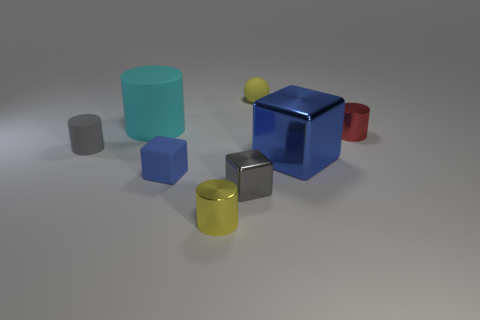There is a tiny yellow thing in front of the tiny yellow thing behind the yellow cylinder; what shape is it?
Ensure brevity in your answer.  Cylinder. There is a cyan matte thing; does it have the same shape as the gray thing that is left of the big rubber cylinder?
Ensure brevity in your answer.  Yes. How many blue blocks are to the right of the small yellow rubber sphere that is behind the blue matte cube?
Your response must be concise. 1. There is another small thing that is the same shape as the blue rubber thing; what is it made of?
Offer a terse response. Metal. What number of purple things are tiny blocks or metal things?
Give a very brief answer. 0. Is there anything else of the same color as the big cylinder?
Your answer should be very brief. No. There is a tiny rubber thing that is to the right of the rubber object in front of the small gray matte cylinder; what is its color?
Your response must be concise. Yellow. Is the number of tiny gray metallic objects that are behind the large blue shiny cube less than the number of large matte cylinders in front of the yellow shiny object?
Make the answer very short. No. There is a big object that is the same color as the rubber cube; what is its material?
Provide a short and direct response. Metal. How many objects are either yellow things in front of the small red shiny object or small red shiny cylinders?
Offer a terse response. 2. 